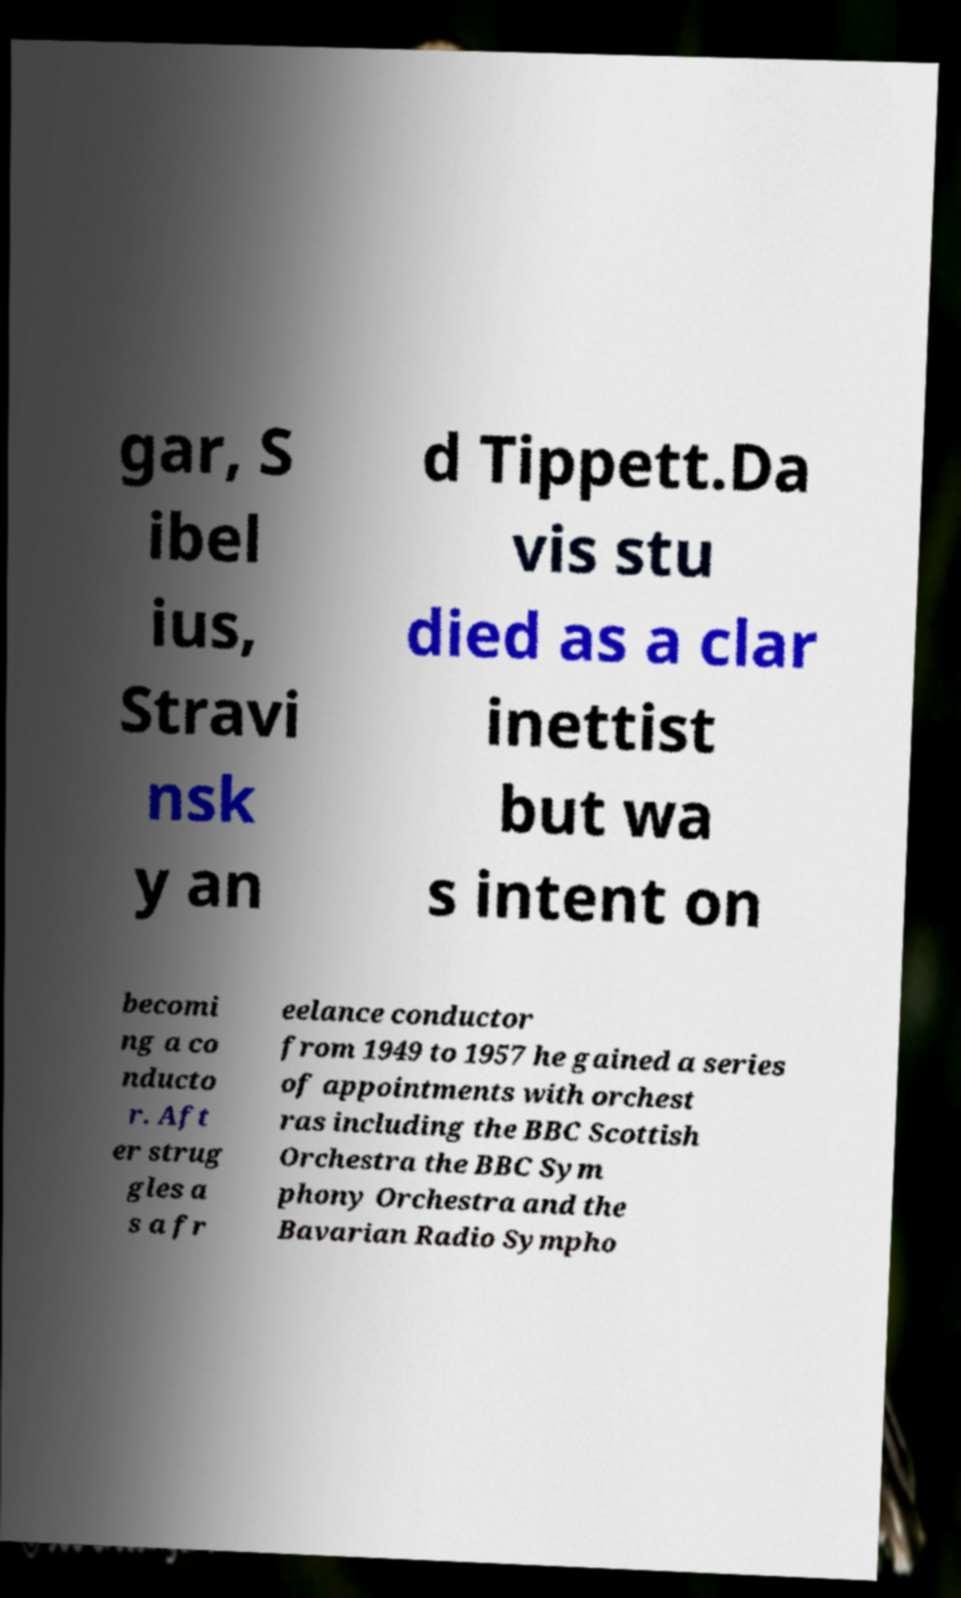There's text embedded in this image that I need extracted. Can you transcribe it verbatim? gar, S ibel ius, Stravi nsk y an d Tippett.Da vis stu died as a clar inettist but wa s intent on becomi ng a co nducto r. Aft er strug gles a s a fr eelance conductor from 1949 to 1957 he gained a series of appointments with orchest ras including the BBC Scottish Orchestra the BBC Sym phony Orchestra and the Bavarian Radio Sympho 